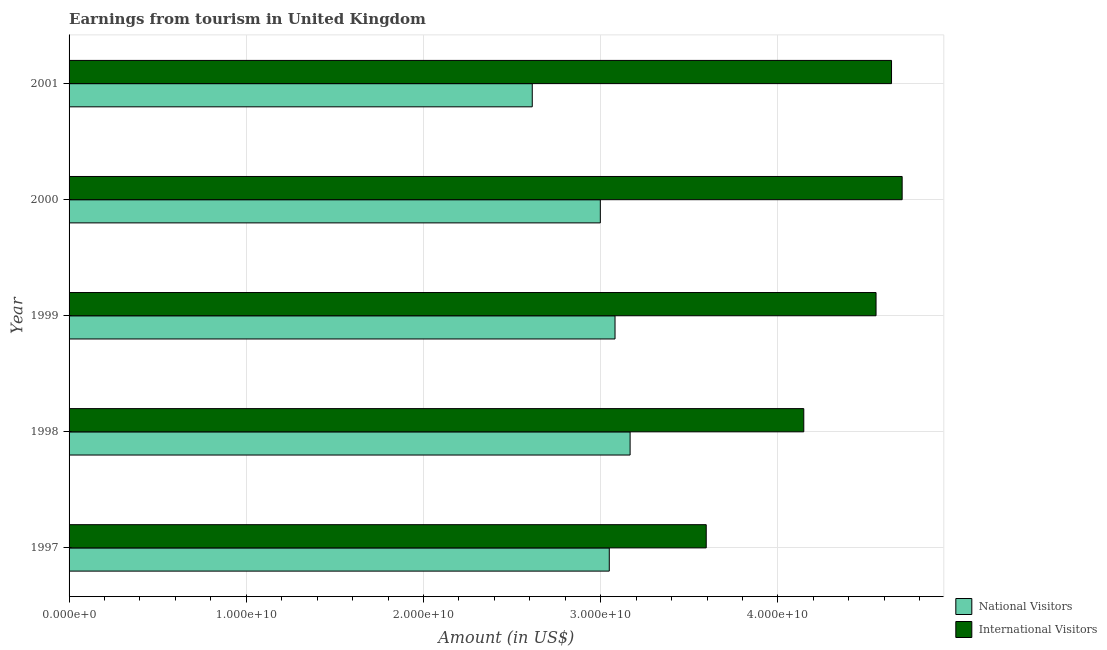How many different coloured bars are there?
Your answer should be compact. 2. How many groups of bars are there?
Offer a very short reply. 5. Are the number of bars on each tick of the Y-axis equal?
Your response must be concise. Yes. How many bars are there on the 3rd tick from the top?
Give a very brief answer. 2. What is the label of the 1st group of bars from the top?
Your answer should be compact. 2001. In how many cases, is the number of bars for a given year not equal to the number of legend labels?
Offer a very short reply. 0. What is the amount earned from national visitors in 1997?
Provide a short and direct response. 3.05e+1. Across all years, what is the maximum amount earned from national visitors?
Give a very brief answer. 3.17e+1. Across all years, what is the minimum amount earned from international visitors?
Offer a terse response. 3.60e+1. In which year was the amount earned from international visitors maximum?
Ensure brevity in your answer.  2000. What is the total amount earned from international visitors in the graph?
Ensure brevity in your answer.  2.16e+11. What is the difference between the amount earned from international visitors in 2000 and that in 2001?
Give a very brief answer. 5.99e+08. What is the difference between the amount earned from national visitors in 2000 and the amount earned from international visitors in 1998?
Ensure brevity in your answer.  -1.15e+1. What is the average amount earned from national visitors per year?
Offer a terse response. 2.98e+1. In the year 1999, what is the difference between the amount earned from national visitors and amount earned from international visitors?
Your response must be concise. -1.47e+1. What is the ratio of the amount earned from national visitors in 1997 to that in 2001?
Ensure brevity in your answer.  1.17. Is the difference between the amount earned from national visitors in 1998 and 2001 greater than the difference between the amount earned from international visitors in 1998 and 2001?
Offer a terse response. Yes. What is the difference between the highest and the second highest amount earned from national visitors?
Make the answer very short. 8.51e+08. What is the difference between the highest and the lowest amount earned from national visitors?
Your answer should be compact. 5.52e+09. In how many years, is the amount earned from national visitors greater than the average amount earned from national visitors taken over all years?
Your answer should be compact. 4. Is the sum of the amount earned from national visitors in 1999 and 2001 greater than the maximum amount earned from international visitors across all years?
Your answer should be very brief. Yes. What does the 2nd bar from the top in 2000 represents?
Provide a succinct answer. National Visitors. What does the 1st bar from the bottom in 2001 represents?
Offer a very short reply. National Visitors. How many bars are there?
Your answer should be very brief. 10. Are all the bars in the graph horizontal?
Make the answer very short. Yes. How many years are there in the graph?
Your answer should be very brief. 5. How many legend labels are there?
Provide a short and direct response. 2. How are the legend labels stacked?
Your answer should be compact. Vertical. What is the title of the graph?
Keep it short and to the point. Earnings from tourism in United Kingdom. Does "Transport services" appear as one of the legend labels in the graph?
Keep it short and to the point. No. What is the Amount (in US$) in National Visitors in 1997?
Your answer should be compact. 3.05e+1. What is the Amount (in US$) in International Visitors in 1997?
Keep it short and to the point. 3.60e+1. What is the Amount (in US$) in National Visitors in 1998?
Your response must be concise. 3.17e+1. What is the Amount (in US$) of International Visitors in 1998?
Provide a short and direct response. 4.15e+1. What is the Amount (in US$) in National Visitors in 1999?
Your answer should be compact. 3.08e+1. What is the Amount (in US$) in International Visitors in 1999?
Give a very brief answer. 4.55e+1. What is the Amount (in US$) in National Visitors in 2000?
Provide a short and direct response. 3.00e+1. What is the Amount (in US$) of International Visitors in 2000?
Offer a terse response. 4.70e+1. What is the Amount (in US$) of National Visitors in 2001?
Keep it short and to the point. 2.61e+1. What is the Amount (in US$) in International Visitors in 2001?
Your response must be concise. 4.64e+1. Across all years, what is the maximum Amount (in US$) of National Visitors?
Ensure brevity in your answer.  3.17e+1. Across all years, what is the maximum Amount (in US$) in International Visitors?
Provide a succinct answer. 4.70e+1. Across all years, what is the minimum Amount (in US$) of National Visitors?
Ensure brevity in your answer.  2.61e+1. Across all years, what is the minimum Amount (in US$) in International Visitors?
Keep it short and to the point. 3.60e+1. What is the total Amount (in US$) of National Visitors in the graph?
Offer a terse response. 1.49e+11. What is the total Amount (in US$) of International Visitors in the graph?
Your response must be concise. 2.16e+11. What is the difference between the Amount (in US$) of National Visitors in 1997 and that in 1998?
Offer a very short reply. -1.18e+09. What is the difference between the Amount (in US$) in International Visitors in 1997 and that in 1998?
Offer a very short reply. -5.50e+09. What is the difference between the Amount (in US$) of National Visitors in 1997 and that in 1999?
Offer a terse response. -3.24e+08. What is the difference between the Amount (in US$) of International Visitors in 1997 and that in 1999?
Make the answer very short. -9.58e+09. What is the difference between the Amount (in US$) in National Visitors in 1997 and that in 2000?
Offer a terse response. 5.05e+08. What is the difference between the Amount (in US$) of International Visitors in 1997 and that in 2000?
Make the answer very short. -1.11e+1. What is the difference between the Amount (in US$) in National Visitors in 1997 and that in 2001?
Keep it short and to the point. 4.35e+09. What is the difference between the Amount (in US$) in International Visitors in 1997 and that in 2001?
Make the answer very short. -1.05e+1. What is the difference between the Amount (in US$) in National Visitors in 1998 and that in 1999?
Your answer should be very brief. 8.51e+08. What is the difference between the Amount (in US$) in International Visitors in 1998 and that in 1999?
Ensure brevity in your answer.  -4.08e+09. What is the difference between the Amount (in US$) of National Visitors in 1998 and that in 2000?
Give a very brief answer. 1.68e+09. What is the difference between the Amount (in US$) of International Visitors in 1998 and that in 2000?
Provide a short and direct response. -5.55e+09. What is the difference between the Amount (in US$) in National Visitors in 1998 and that in 2001?
Keep it short and to the point. 5.52e+09. What is the difference between the Amount (in US$) of International Visitors in 1998 and that in 2001?
Offer a terse response. -4.95e+09. What is the difference between the Amount (in US$) in National Visitors in 1999 and that in 2000?
Provide a short and direct response. 8.29e+08. What is the difference between the Amount (in US$) of International Visitors in 1999 and that in 2000?
Provide a short and direct response. -1.47e+09. What is the difference between the Amount (in US$) of National Visitors in 1999 and that in 2001?
Make the answer very short. 4.67e+09. What is the difference between the Amount (in US$) in International Visitors in 1999 and that in 2001?
Offer a terse response. -8.74e+08. What is the difference between the Amount (in US$) in National Visitors in 2000 and that in 2001?
Your response must be concise. 3.84e+09. What is the difference between the Amount (in US$) in International Visitors in 2000 and that in 2001?
Keep it short and to the point. 5.99e+08. What is the difference between the Amount (in US$) in National Visitors in 1997 and the Amount (in US$) in International Visitors in 1998?
Your response must be concise. -1.10e+1. What is the difference between the Amount (in US$) of National Visitors in 1997 and the Amount (in US$) of International Visitors in 1999?
Your answer should be compact. -1.51e+1. What is the difference between the Amount (in US$) in National Visitors in 1997 and the Amount (in US$) in International Visitors in 2000?
Keep it short and to the point. -1.65e+1. What is the difference between the Amount (in US$) of National Visitors in 1997 and the Amount (in US$) of International Visitors in 2001?
Give a very brief answer. -1.59e+1. What is the difference between the Amount (in US$) of National Visitors in 1998 and the Amount (in US$) of International Visitors in 1999?
Your answer should be compact. -1.39e+1. What is the difference between the Amount (in US$) of National Visitors in 1998 and the Amount (in US$) of International Visitors in 2000?
Make the answer very short. -1.54e+1. What is the difference between the Amount (in US$) of National Visitors in 1998 and the Amount (in US$) of International Visitors in 2001?
Offer a terse response. -1.48e+1. What is the difference between the Amount (in US$) of National Visitors in 1999 and the Amount (in US$) of International Visitors in 2000?
Offer a very short reply. -1.62e+1. What is the difference between the Amount (in US$) in National Visitors in 1999 and the Amount (in US$) in International Visitors in 2001?
Ensure brevity in your answer.  -1.56e+1. What is the difference between the Amount (in US$) in National Visitors in 2000 and the Amount (in US$) in International Visitors in 2001?
Your answer should be very brief. -1.64e+1. What is the average Amount (in US$) of National Visitors per year?
Offer a very short reply. 2.98e+1. What is the average Amount (in US$) in International Visitors per year?
Keep it short and to the point. 4.33e+1. In the year 1997, what is the difference between the Amount (in US$) in National Visitors and Amount (in US$) in International Visitors?
Ensure brevity in your answer.  -5.47e+09. In the year 1998, what is the difference between the Amount (in US$) in National Visitors and Amount (in US$) in International Visitors?
Ensure brevity in your answer.  -9.80e+09. In the year 1999, what is the difference between the Amount (in US$) of National Visitors and Amount (in US$) of International Visitors?
Make the answer very short. -1.47e+1. In the year 2000, what is the difference between the Amount (in US$) in National Visitors and Amount (in US$) in International Visitors?
Provide a succinct answer. -1.70e+1. In the year 2001, what is the difference between the Amount (in US$) in National Visitors and Amount (in US$) in International Visitors?
Your answer should be very brief. -2.03e+1. What is the ratio of the Amount (in US$) in National Visitors in 1997 to that in 1998?
Offer a terse response. 0.96. What is the ratio of the Amount (in US$) in International Visitors in 1997 to that in 1998?
Make the answer very short. 0.87. What is the ratio of the Amount (in US$) in National Visitors in 1997 to that in 1999?
Keep it short and to the point. 0.99. What is the ratio of the Amount (in US$) in International Visitors in 1997 to that in 1999?
Your answer should be compact. 0.79. What is the ratio of the Amount (in US$) in National Visitors in 1997 to that in 2000?
Your response must be concise. 1.02. What is the ratio of the Amount (in US$) in International Visitors in 1997 to that in 2000?
Your answer should be compact. 0.76. What is the ratio of the Amount (in US$) in National Visitors in 1997 to that in 2001?
Keep it short and to the point. 1.17. What is the ratio of the Amount (in US$) of International Visitors in 1997 to that in 2001?
Keep it short and to the point. 0.77. What is the ratio of the Amount (in US$) in National Visitors in 1998 to that in 1999?
Make the answer very short. 1.03. What is the ratio of the Amount (in US$) of International Visitors in 1998 to that in 1999?
Your response must be concise. 0.91. What is the ratio of the Amount (in US$) in National Visitors in 1998 to that in 2000?
Keep it short and to the point. 1.06. What is the ratio of the Amount (in US$) of International Visitors in 1998 to that in 2000?
Ensure brevity in your answer.  0.88. What is the ratio of the Amount (in US$) of National Visitors in 1998 to that in 2001?
Ensure brevity in your answer.  1.21. What is the ratio of the Amount (in US$) in International Visitors in 1998 to that in 2001?
Keep it short and to the point. 0.89. What is the ratio of the Amount (in US$) in National Visitors in 1999 to that in 2000?
Offer a terse response. 1.03. What is the ratio of the Amount (in US$) of International Visitors in 1999 to that in 2000?
Your response must be concise. 0.97. What is the ratio of the Amount (in US$) in National Visitors in 1999 to that in 2001?
Make the answer very short. 1.18. What is the ratio of the Amount (in US$) in International Visitors in 1999 to that in 2001?
Ensure brevity in your answer.  0.98. What is the ratio of the Amount (in US$) of National Visitors in 2000 to that in 2001?
Your answer should be compact. 1.15. What is the ratio of the Amount (in US$) in International Visitors in 2000 to that in 2001?
Your answer should be very brief. 1.01. What is the difference between the highest and the second highest Amount (in US$) of National Visitors?
Give a very brief answer. 8.51e+08. What is the difference between the highest and the second highest Amount (in US$) in International Visitors?
Your response must be concise. 5.99e+08. What is the difference between the highest and the lowest Amount (in US$) of National Visitors?
Offer a very short reply. 5.52e+09. What is the difference between the highest and the lowest Amount (in US$) in International Visitors?
Provide a succinct answer. 1.11e+1. 